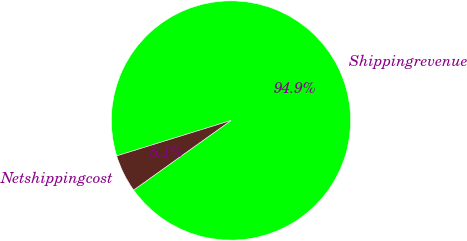<chart> <loc_0><loc_0><loc_500><loc_500><pie_chart><fcel>Shippingrevenue<fcel>Netshippingcost<nl><fcel>94.91%<fcel>5.09%<nl></chart> 